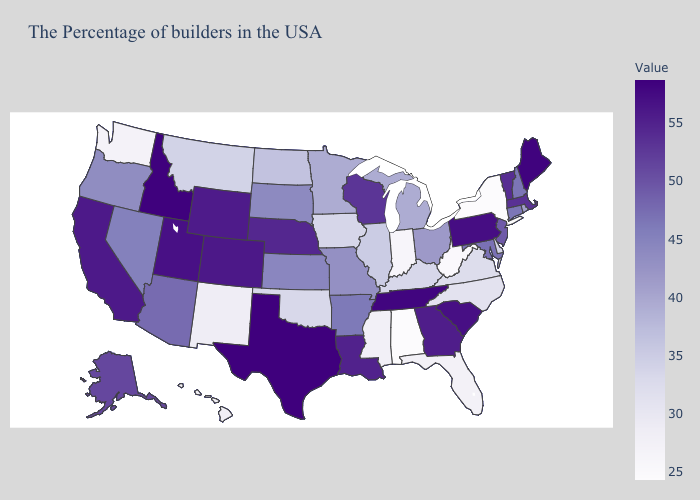Does Florida have a higher value than Nebraska?
Short answer required. No. Does New York have the lowest value in the USA?
Write a very short answer. Yes. Which states have the lowest value in the USA?
Write a very short answer. New York. Does Montana have a lower value than New Mexico?
Give a very brief answer. No. Which states have the lowest value in the Northeast?
Give a very brief answer. New York. Among the states that border Louisiana , does Texas have the highest value?
Keep it brief. Yes. 